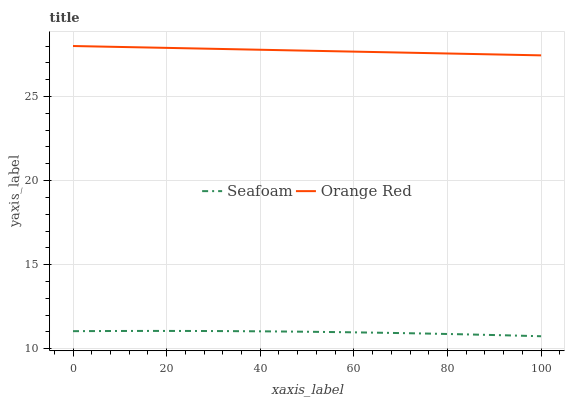Does Orange Red have the minimum area under the curve?
Answer yes or no. No. Is Orange Red the roughest?
Answer yes or no. No. Does Orange Red have the lowest value?
Answer yes or no. No. Is Seafoam less than Orange Red?
Answer yes or no. Yes. Is Orange Red greater than Seafoam?
Answer yes or no. Yes. Does Seafoam intersect Orange Red?
Answer yes or no. No. 